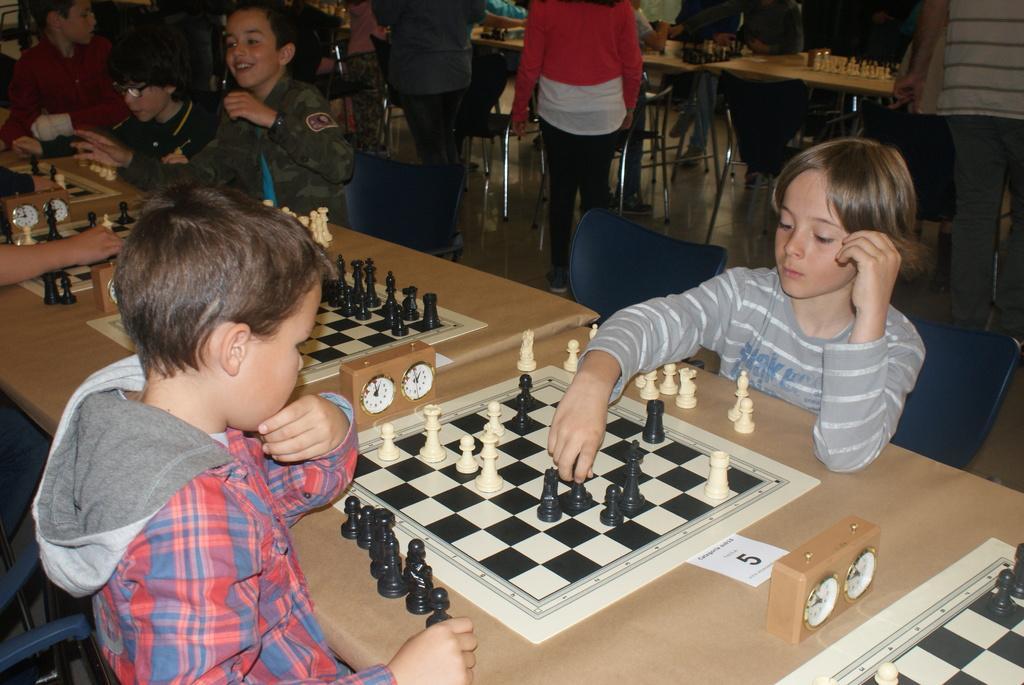Could you give a brief overview of what you see in this image? In the given image we can see that, there are children sitting around table. This is a chess board, clock and there are many chairs. 